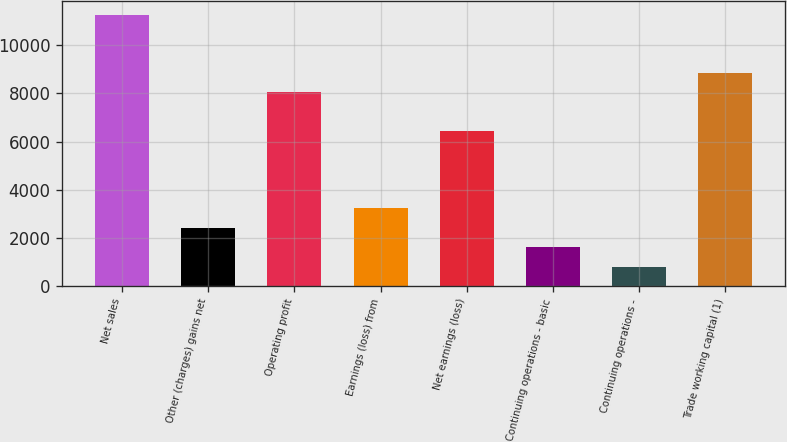Convert chart. <chart><loc_0><loc_0><loc_500><loc_500><bar_chart><fcel>Net sales<fcel>Other (charges) gains net<fcel>Operating profit<fcel>Earnings (loss) from<fcel>Net earnings (loss)<fcel>Continuing operations - basic<fcel>Continuing operations -<fcel>Trade working capital (1)<nl><fcel>11271.3<fcel>2415.4<fcel>8050.96<fcel>3220.48<fcel>6440.8<fcel>1610.32<fcel>805.24<fcel>8856.04<nl></chart> 